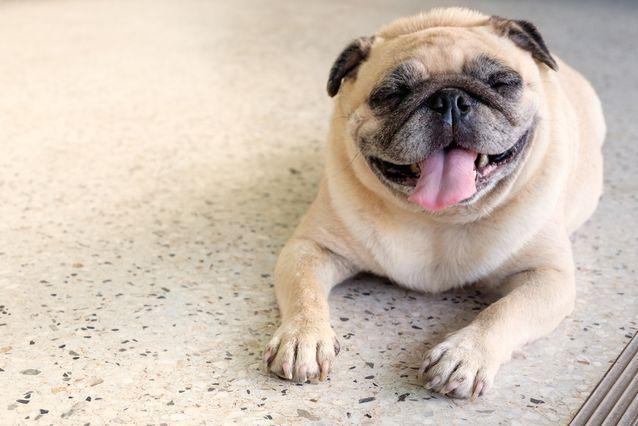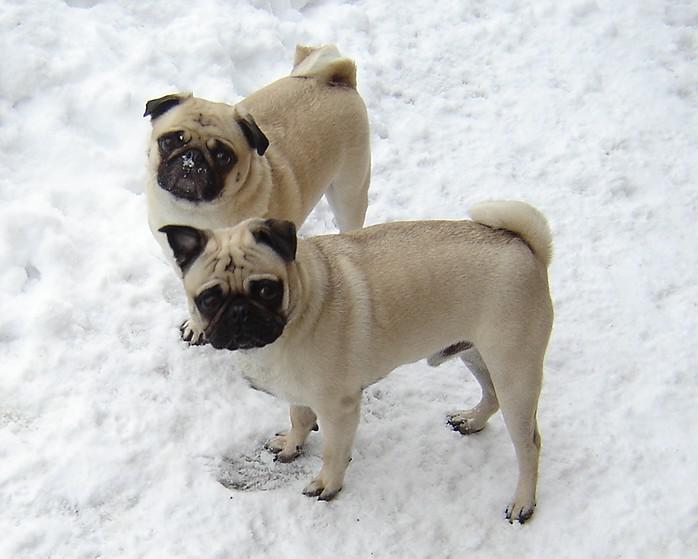The first image is the image on the left, the second image is the image on the right. Evaluate the accuracy of this statement regarding the images: "In total, two pug tails are visible.". Is it true? Answer yes or no. Yes. 